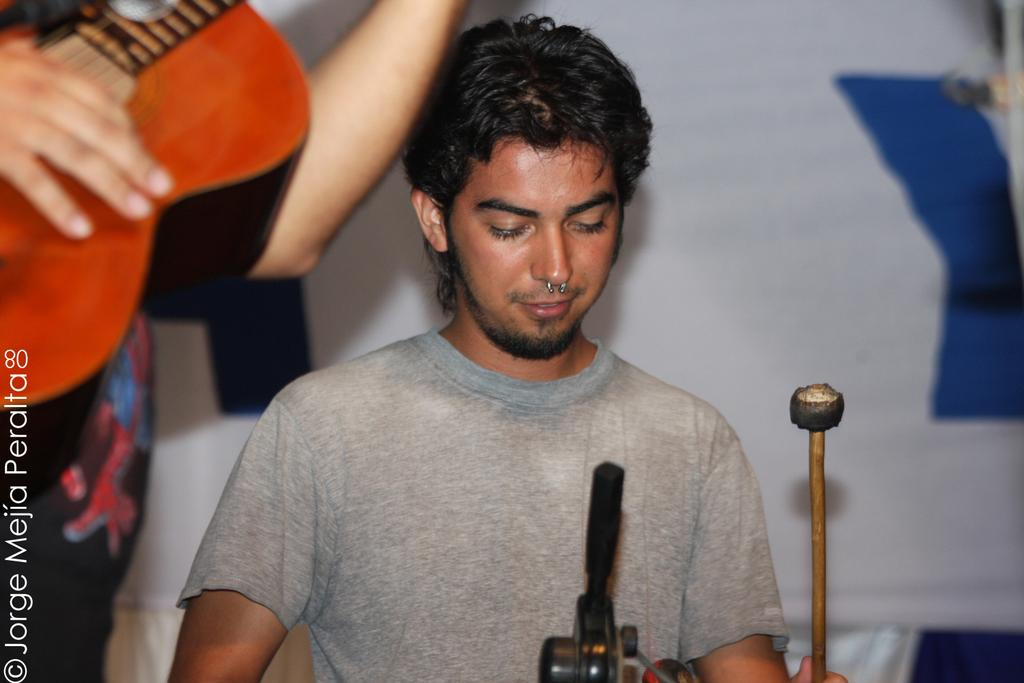What is the main subject of the image? The main subject of the image is a man. Can you describe any unique features of the man? Yes, the man has a nose ring. What is the man holding in the image? The man is holding a stick, possibly playing drums. Are there any other people in the image? Yes, there is another person in the image. What is the other person holding? The other person is holding a guitar. What type of air can be seen coming out of the guitar in the image? There is no air coming out of the guitar in the image; it is a musical instrument. Can you describe the view from the friend's perspective in the image? There is no friend present in the image, and therefore no view from a friend's perspective can be described. 